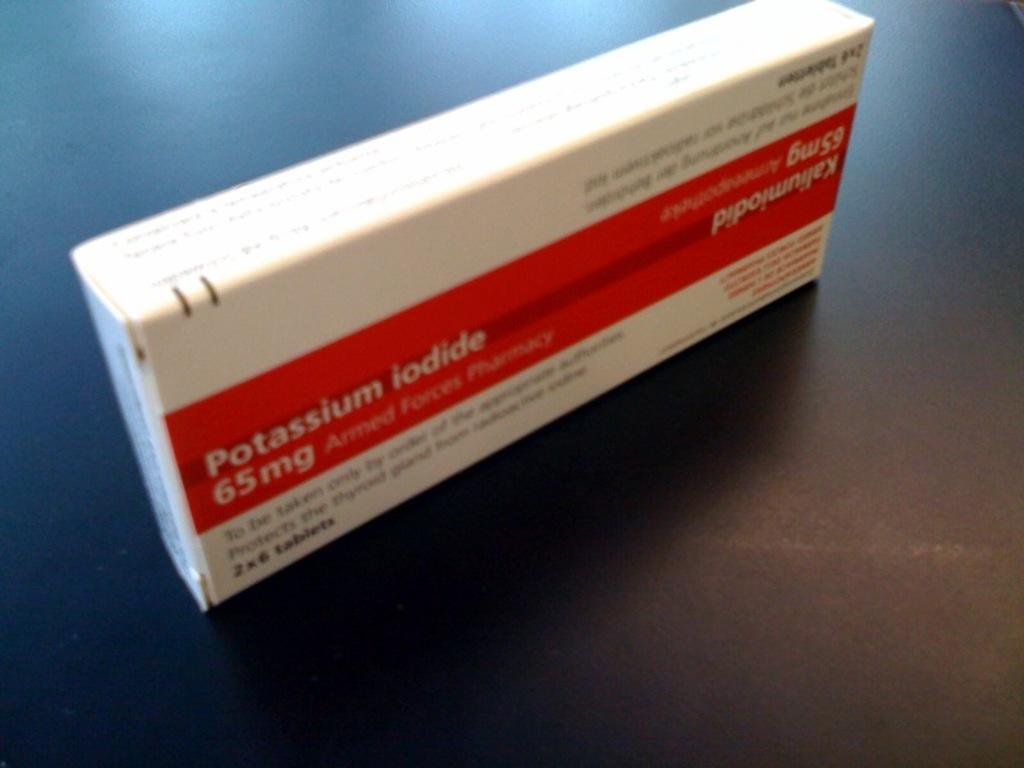How many milligrams of potassium iodide?
Make the answer very short. 65. 